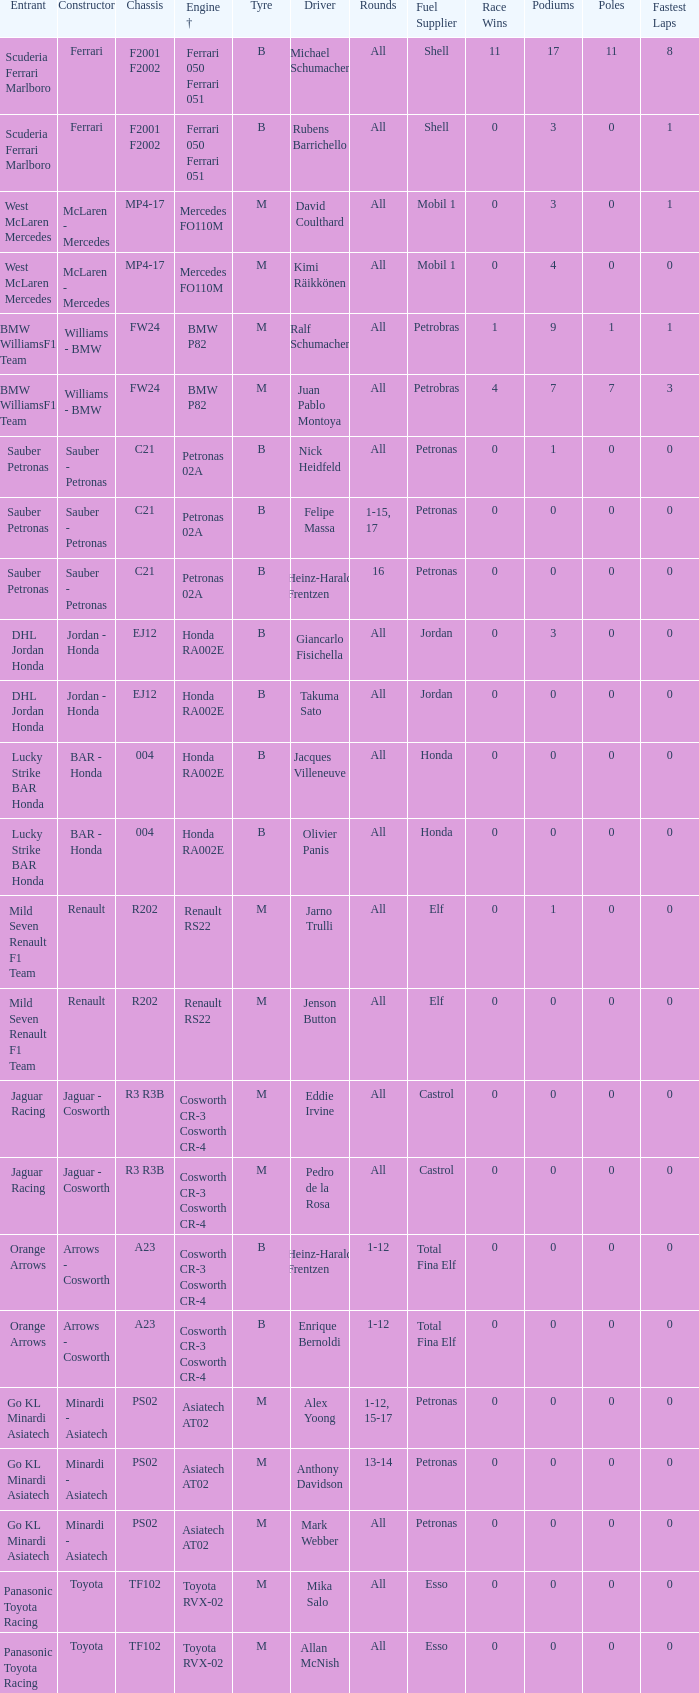What is the chassis when the tyre is b, the engine is ferrari 050 ferrari 051 and the driver is rubens barrichello? F2001 F2002. 